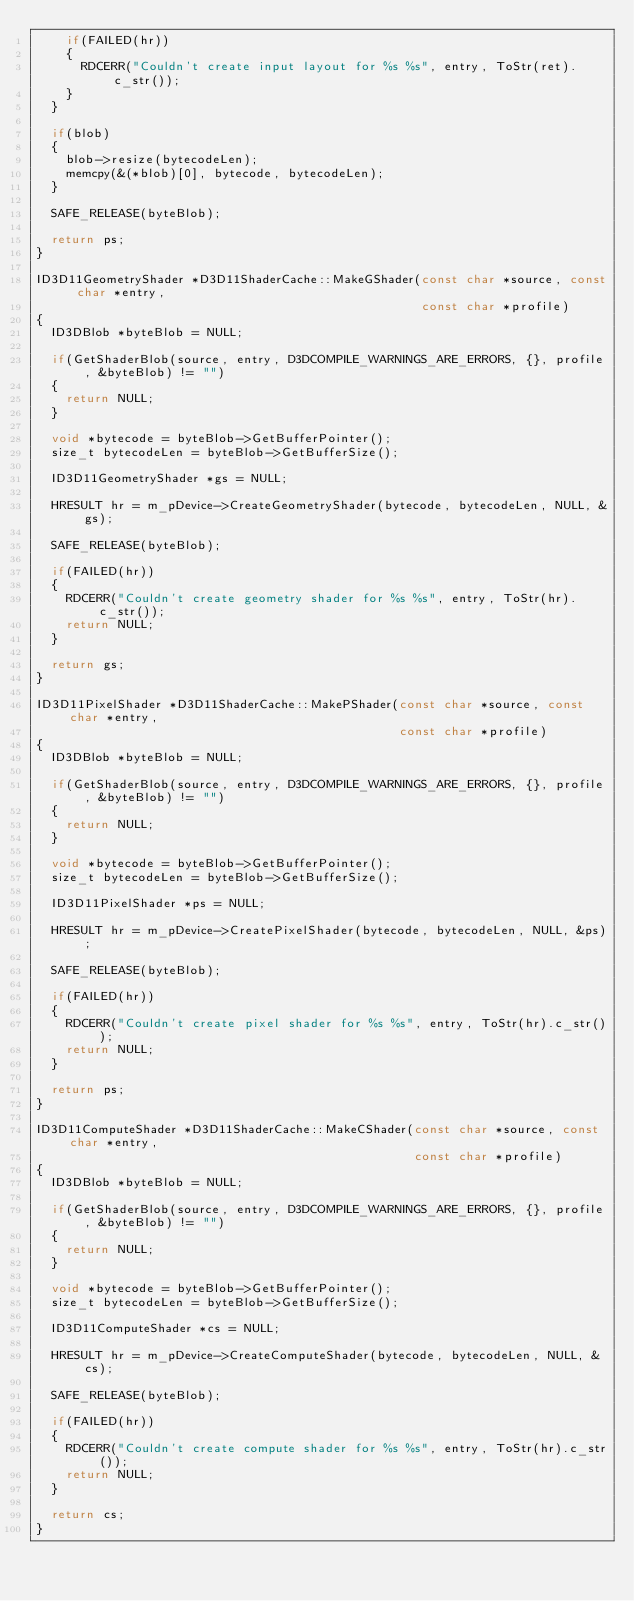<code> <loc_0><loc_0><loc_500><loc_500><_C++_>    if(FAILED(hr))
    {
      RDCERR("Couldn't create input layout for %s %s", entry, ToStr(ret).c_str());
    }
  }

  if(blob)
  {
    blob->resize(bytecodeLen);
    memcpy(&(*blob)[0], bytecode, bytecodeLen);
  }

  SAFE_RELEASE(byteBlob);

  return ps;
}

ID3D11GeometryShader *D3D11ShaderCache::MakeGShader(const char *source, const char *entry,
                                                    const char *profile)
{
  ID3DBlob *byteBlob = NULL;

  if(GetShaderBlob(source, entry, D3DCOMPILE_WARNINGS_ARE_ERRORS, {}, profile, &byteBlob) != "")
  {
    return NULL;
  }

  void *bytecode = byteBlob->GetBufferPointer();
  size_t bytecodeLen = byteBlob->GetBufferSize();

  ID3D11GeometryShader *gs = NULL;

  HRESULT hr = m_pDevice->CreateGeometryShader(bytecode, bytecodeLen, NULL, &gs);

  SAFE_RELEASE(byteBlob);

  if(FAILED(hr))
  {
    RDCERR("Couldn't create geometry shader for %s %s", entry, ToStr(hr).c_str());
    return NULL;
  }

  return gs;
}

ID3D11PixelShader *D3D11ShaderCache::MakePShader(const char *source, const char *entry,
                                                 const char *profile)
{
  ID3DBlob *byteBlob = NULL;

  if(GetShaderBlob(source, entry, D3DCOMPILE_WARNINGS_ARE_ERRORS, {}, profile, &byteBlob) != "")
  {
    return NULL;
  }

  void *bytecode = byteBlob->GetBufferPointer();
  size_t bytecodeLen = byteBlob->GetBufferSize();

  ID3D11PixelShader *ps = NULL;

  HRESULT hr = m_pDevice->CreatePixelShader(bytecode, bytecodeLen, NULL, &ps);

  SAFE_RELEASE(byteBlob);

  if(FAILED(hr))
  {
    RDCERR("Couldn't create pixel shader for %s %s", entry, ToStr(hr).c_str());
    return NULL;
  }

  return ps;
}

ID3D11ComputeShader *D3D11ShaderCache::MakeCShader(const char *source, const char *entry,
                                                   const char *profile)
{
  ID3DBlob *byteBlob = NULL;

  if(GetShaderBlob(source, entry, D3DCOMPILE_WARNINGS_ARE_ERRORS, {}, profile, &byteBlob) != "")
  {
    return NULL;
  }

  void *bytecode = byteBlob->GetBufferPointer();
  size_t bytecodeLen = byteBlob->GetBufferSize();

  ID3D11ComputeShader *cs = NULL;

  HRESULT hr = m_pDevice->CreateComputeShader(bytecode, bytecodeLen, NULL, &cs);

  SAFE_RELEASE(byteBlob);

  if(FAILED(hr))
  {
    RDCERR("Couldn't create compute shader for %s %s", entry, ToStr(hr).c_str());
    return NULL;
  }

  return cs;
}
</code> 